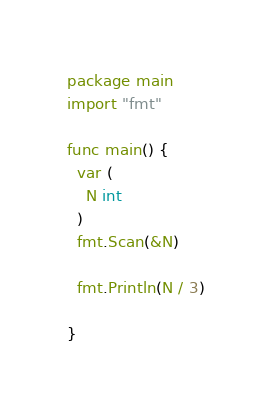<code> <loc_0><loc_0><loc_500><loc_500><_Go_>package main
import "fmt"

func main() {
  var (
    N int
  )
  fmt.Scan(&N)

  fmt.Println(N / 3)
  
}
</code> 